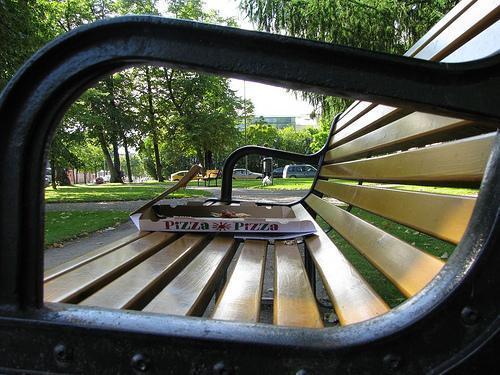How many cars are in the picture?
Give a very brief answer. 3. How many men are in the truck?
Give a very brief answer. 0. 